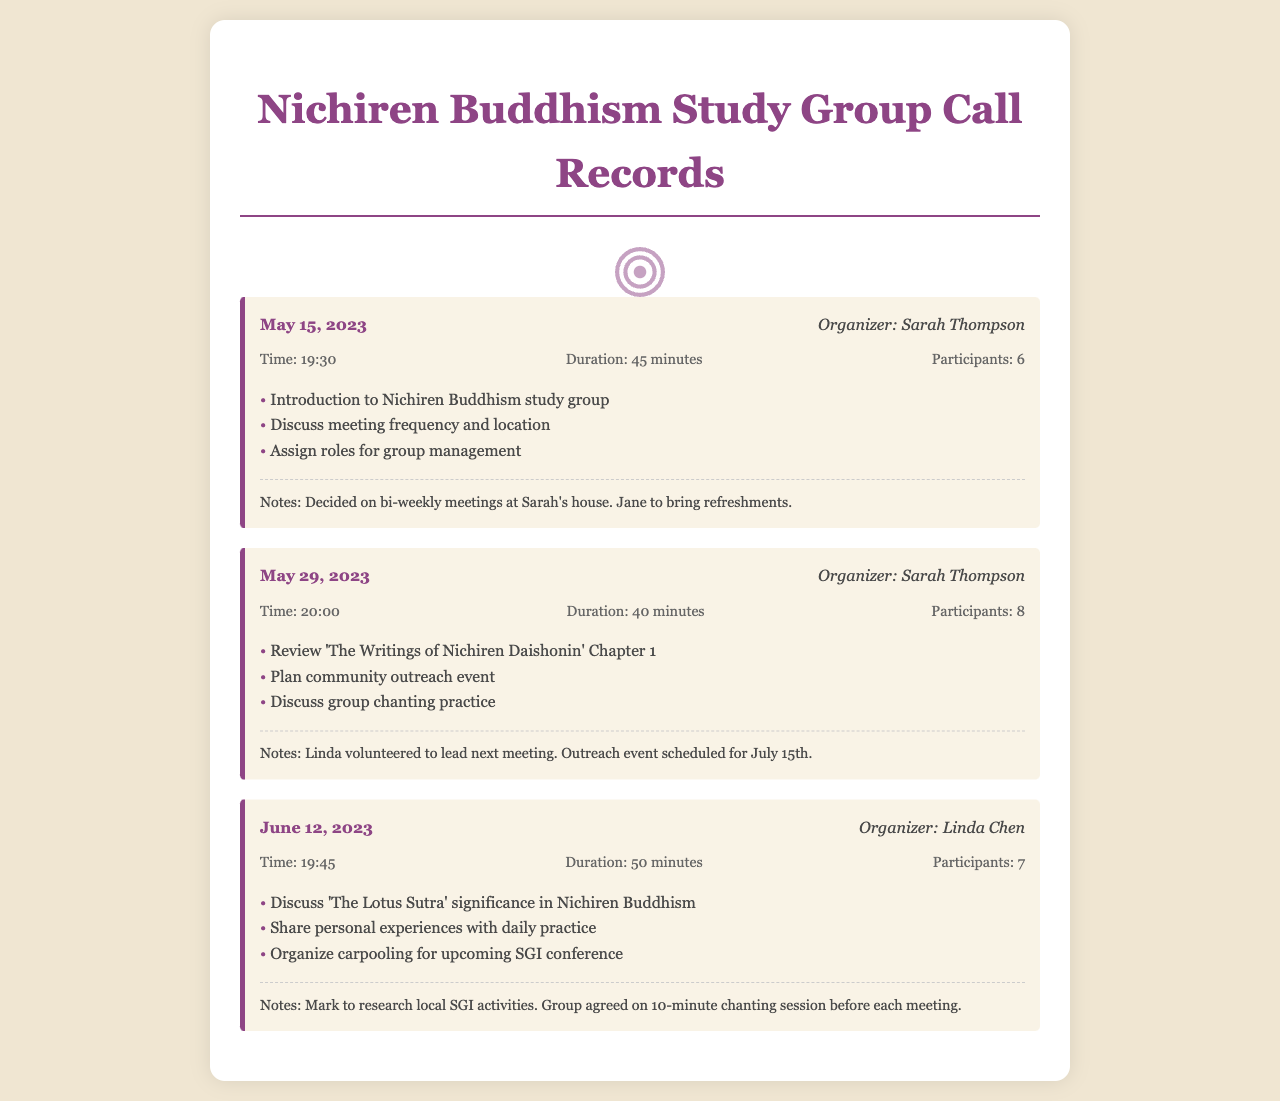What is the date of the first conference call? The date of the first conference call is specifically mentioned in the document as May 15, 2023.
Answer: May 15, 2023 Who organized the second call? The document lists the organizer for the second call as Sarah Thompson.
Answer: Sarah Thompson How many participants joined the call on June 12, 2023? The number of participants for the call on June 12, 2023, is stated as 7 in the document.
Answer: 7 What was one of the agendas discussed on May 29, 2023? One of the agendas for the May 29, 2023 call includes reviewing Chapter 1 of 'The Writings of Nichiren Daishonin'.
Answer: Review 'The Writings of Nichiren Daishonin' Chapter 1 What is the frequency of the meetings decided during the first call? The frequency of meetings was decided to be bi-weekly during the first call on May 15, 2023.
Answer: Bi-weekly Who volunteered to lead the next meeting after the May 29 call? The document mentions that Linda volunteered to lead the next meeting after the May 29 call.
Answer: Linda What was the duration of the call on May 15, 2023? The duration of the first call on May 15, 2023 is recorded as 45 minutes.
Answer: 45 minutes What is the significance discussed during the June 12 call? The significance discussed during the June 12 call relates to 'The Lotus Sutra' in Nichiren Buddhism.
Answer: 'The Lotus Sutra' significance 